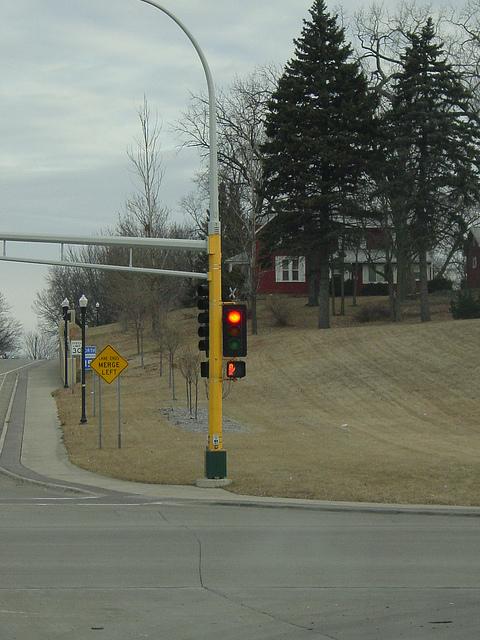Are there any vehicles in the picture?
Give a very brief answer. No. How many cars are on the road?
Give a very brief answer. 0. What is the status of the traffic light?
Be succinct. Red. Is this street passable?
Answer briefly. Yes. Does the light indicate that someone should slow down?
Answer briefly. Yes. Do the trees have foliage?
Answer briefly. No. 